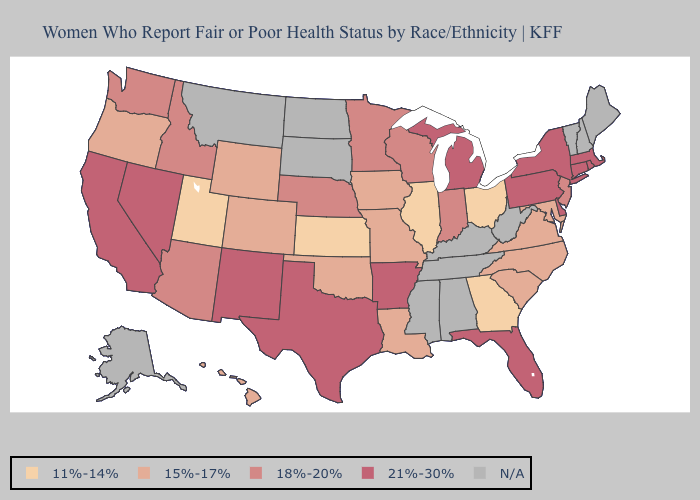Which states have the lowest value in the USA?
Be succinct. Georgia, Illinois, Kansas, Ohio, Utah. Name the states that have a value in the range 21%-30%?
Write a very short answer. Arkansas, California, Connecticut, Delaware, Florida, Massachusetts, Michigan, Nevada, New Mexico, New York, Pennsylvania, Rhode Island, Texas. Among the states that border Arkansas , does Louisiana have the lowest value?
Give a very brief answer. Yes. Name the states that have a value in the range N/A?
Give a very brief answer. Alabama, Alaska, Kentucky, Maine, Mississippi, Montana, New Hampshire, North Dakota, South Dakota, Tennessee, Vermont, West Virginia. Does Wyoming have the highest value in the USA?
Quick response, please. No. Name the states that have a value in the range 18%-20%?
Concise answer only. Arizona, Idaho, Indiana, Minnesota, Nebraska, New Jersey, Washington, Wisconsin. Among the states that border Ohio , which have the lowest value?
Be succinct. Indiana. Is the legend a continuous bar?
Be succinct. No. What is the highest value in states that border Washington?
Give a very brief answer. 18%-20%. Name the states that have a value in the range 21%-30%?
Be succinct. Arkansas, California, Connecticut, Delaware, Florida, Massachusetts, Michigan, Nevada, New Mexico, New York, Pennsylvania, Rhode Island, Texas. Name the states that have a value in the range 11%-14%?
Concise answer only. Georgia, Illinois, Kansas, Ohio, Utah. Name the states that have a value in the range 21%-30%?
Keep it brief. Arkansas, California, Connecticut, Delaware, Florida, Massachusetts, Michigan, Nevada, New Mexico, New York, Pennsylvania, Rhode Island, Texas. What is the value of Delaware?
Be succinct. 21%-30%. Among the states that border Rhode Island , which have the highest value?
Concise answer only. Connecticut, Massachusetts. 